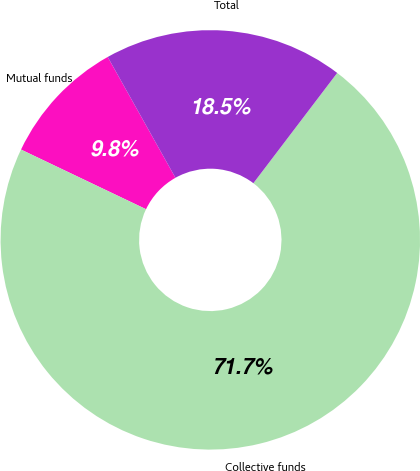Convert chart. <chart><loc_0><loc_0><loc_500><loc_500><pie_chart><fcel>Mutual funds<fcel>Collective funds<fcel>Total<nl><fcel>9.78%<fcel>71.74%<fcel>18.48%<nl></chart> 